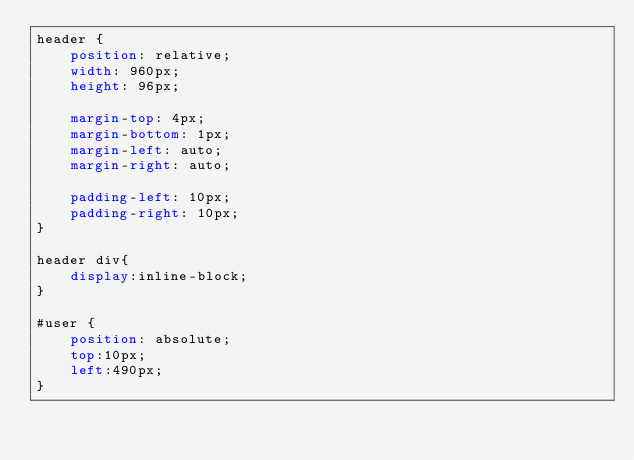<code> <loc_0><loc_0><loc_500><loc_500><_CSS_>header {
    position: relative;
    width: 960px;
    height: 96px;

    margin-top: 4px;
    margin-bottom: 1px;
    margin-left: auto;
    margin-right: auto;

    padding-left: 10px;
    padding-right: 10px;
}

header div{
    display:inline-block;
}

#user {
    position: absolute;
    top:10px;
    left:490px;
}</code> 